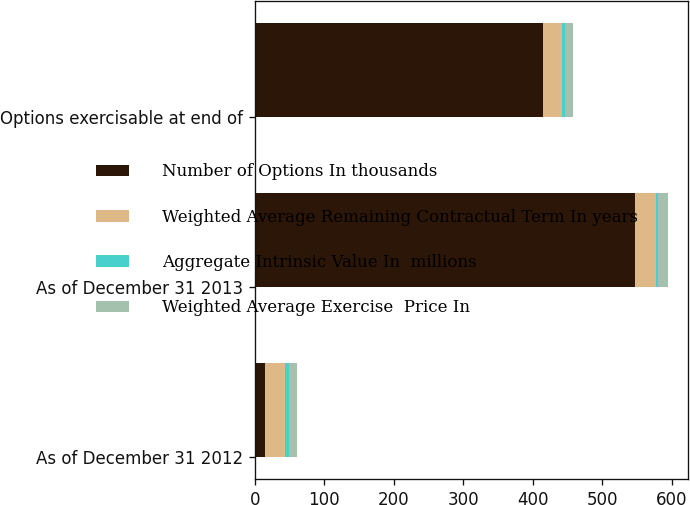<chart> <loc_0><loc_0><loc_500><loc_500><stacked_bar_chart><ecel><fcel>As of December 31 2012<fcel>As of December 31 2013<fcel>Options exercisable at end of<nl><fcel>Number of Options In thousands<fcel>14<fcel>547<fcel>415<nl><fcel>Weighted Average Remaining Contractual Term In years<fcel>29.93<fcel>29.75<fcel>27.44<nl><fcel>Aggregate Intrinsic Value In  millions<fcel>4.4<fcel>3.6<fcel>3.2<nl><fcel>Weighted Average Exercise  Price In<fcel>12<fcel>14<fcel>12<nl></chart> 